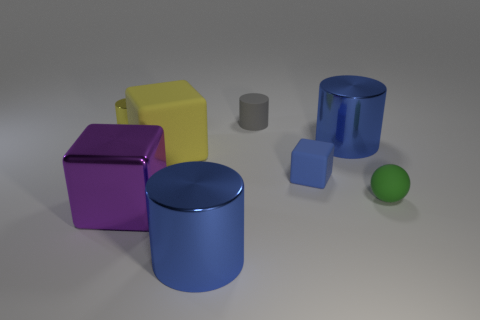Can you tell me the number of objects in the image that have cylindrical shapes? There are two objects in the image with cylindrical shapes: a large blue cylinder lying on its side and a smaller gray cylinder standing upright. 